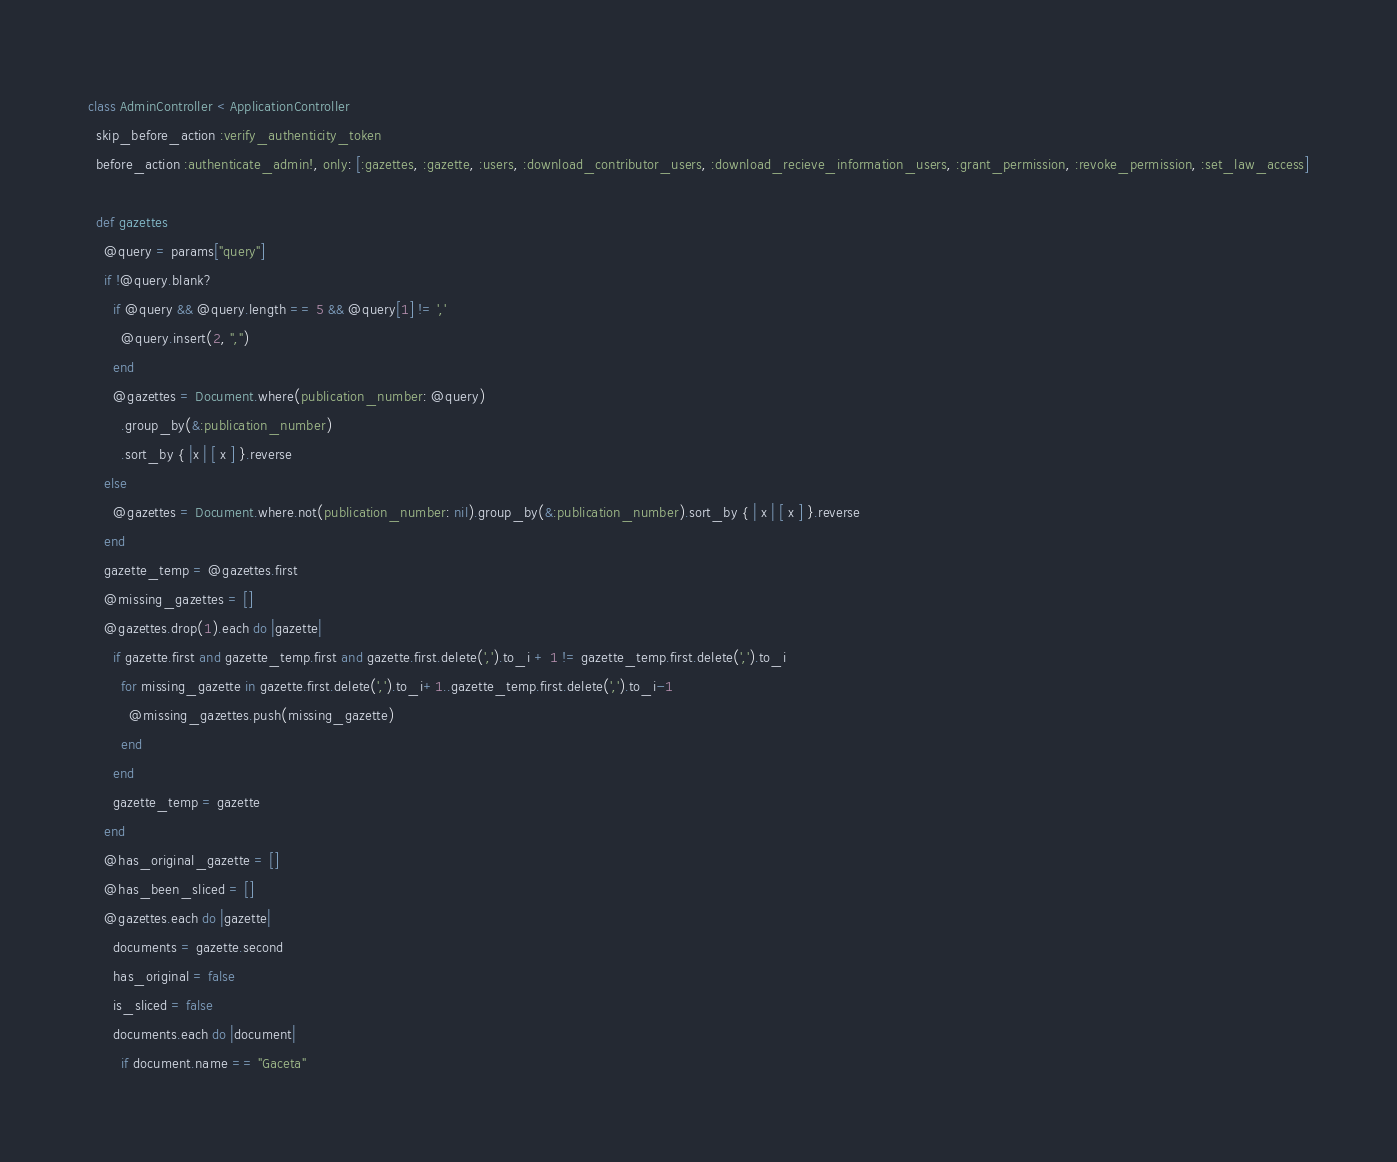<code> <loc_0><loc_0><loc_500><loc_500><_Ruby_>class AdminController < ApplicationController
  skip_before_action :verify_authenticity_token
  before_action :authenticate_admin!, only: [:gazettes, :gazette, :users, :download_contributor_users, :download_recieve_information_users, :grant_permission, :revoke_permission, :set_law_access]

  def gazettes
    @query = params["query"]
    if !@query.blank?
      if @query && @query.length == 5 && @query[1] != ','
        @query.insert(2, ",")
      end
      @gazettes = Document.where(publication_number: @query)
        .group_by(&:publication_number)
        .sort_by { |x | [ x ] }.reverse
    else
      @gazettes = Document.where.not(publication_number: nil).group_by(&:publication_number).sort_by { | x | [ x ] }.reverse
    end
    gazette_temp = @gazettes.first
    @missing_gazettes = []
    @gazettes.drop(1).each do |gazette|
      if gazette.first and gazette_temp.first and gazette.first.delete(',').to_i + 1 != gazette_temp.first.delete(',').to_i
        for missing_gazette in gazette.first.delete(',').to_i+1..gazette_temp.first.delete(',').to_i-1
          @missing_gazettes.push(missing_gazette)
        end
      end
      gazette_temp = gazette
    end
    @has_original_gazette = []
    @has_been_sliced = []
    @gazettes.each do |gazette|
      documents = gazette.second
      has_original = false
      is_sliced = false
      documents.each do |document|
        if document.name == "Gaceta"</code> 